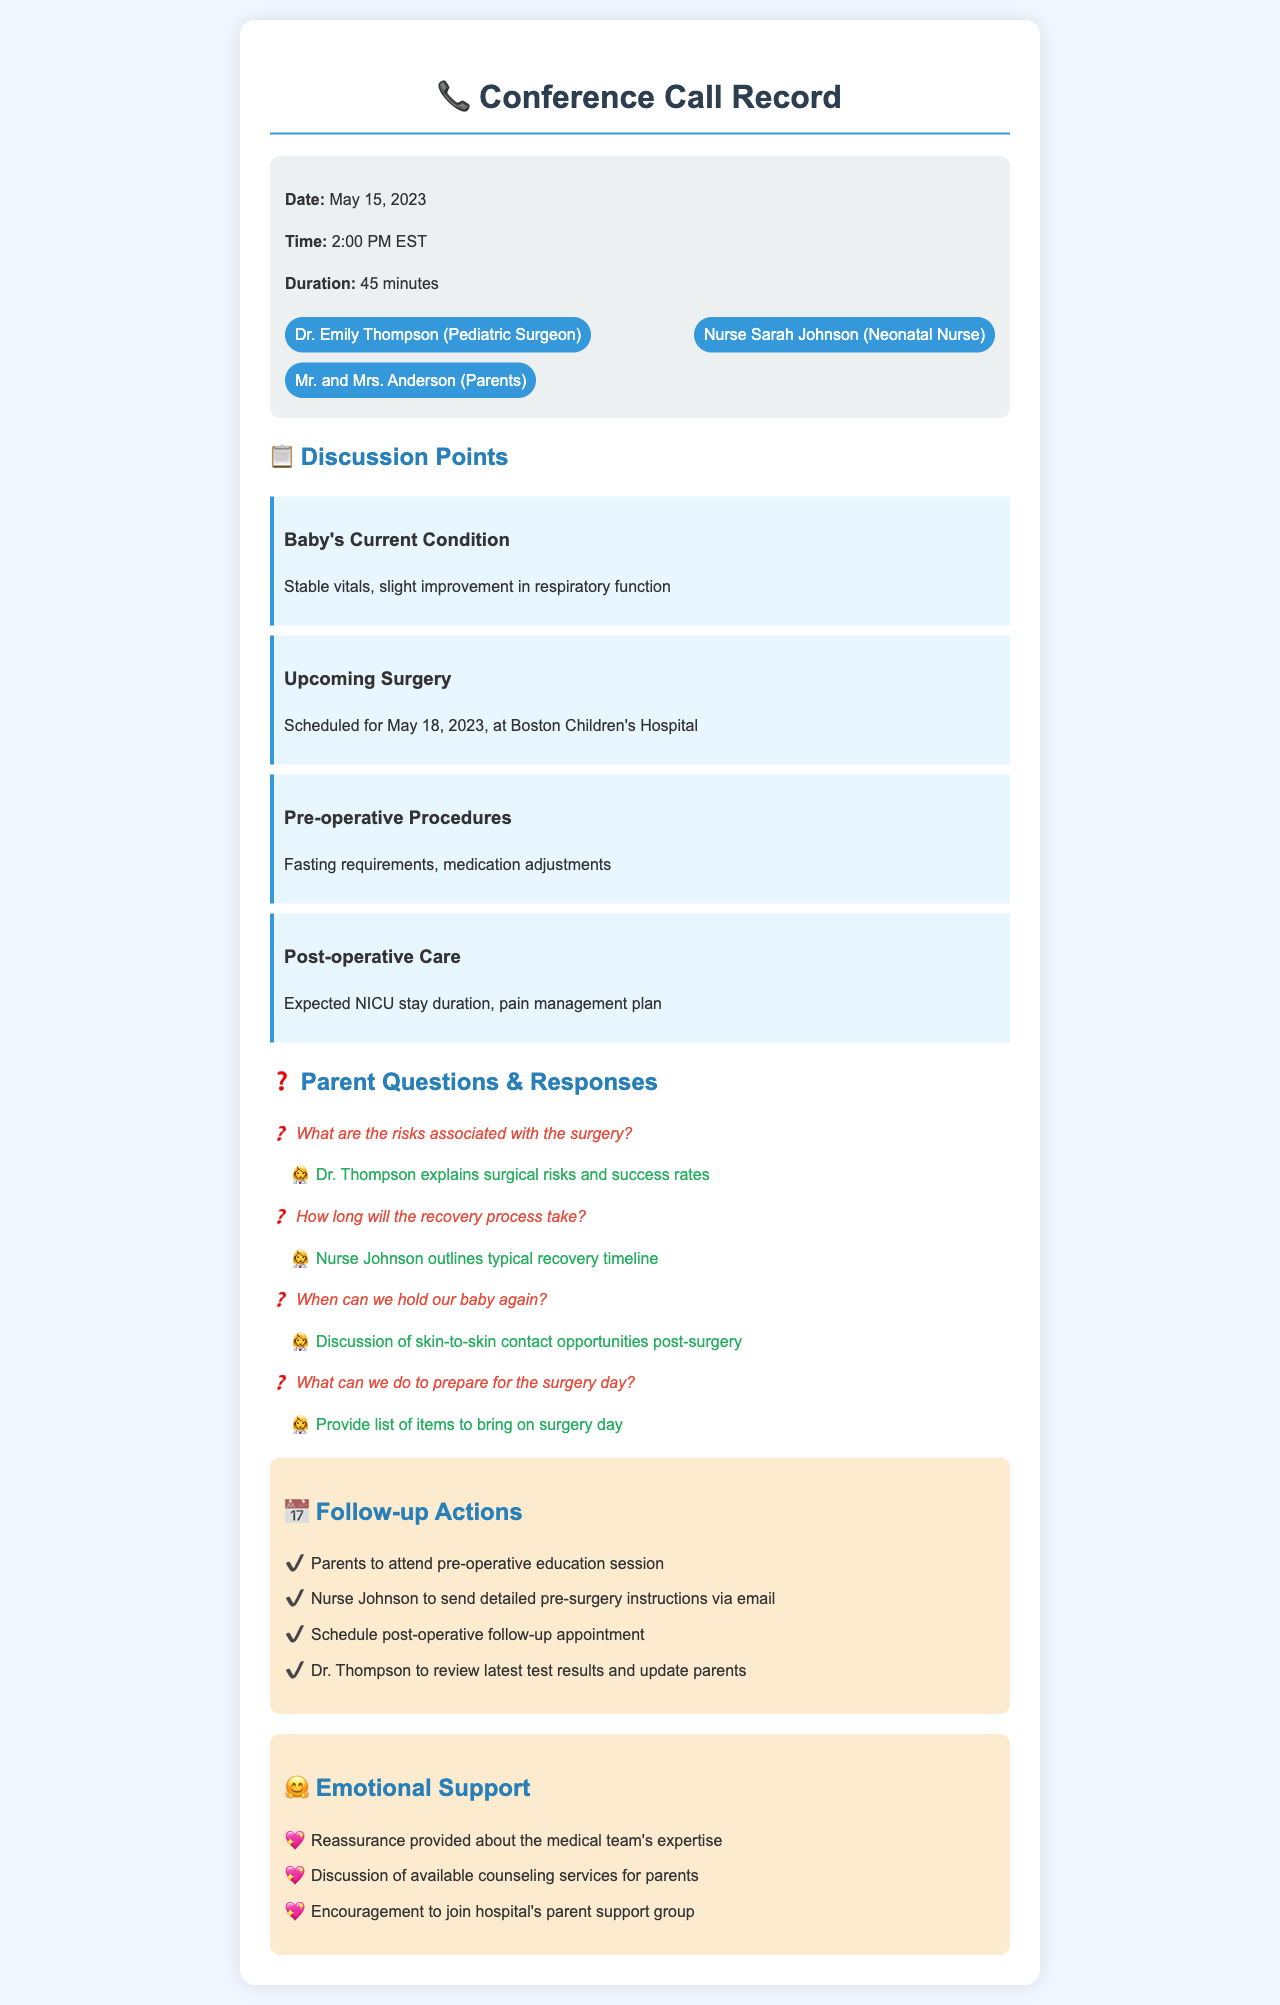What is the date of the conference call? The date of the conference call is explicitly stated in the document under call details.
Answer: May 15, 2023 Who is the pediatric surgeon? The document lists the participants of the call, including the pediatric surgeon's name.
Answer: Dr. Emily Thompson When is the upcoming surgery scheduled? The document includes details about the surgery, mentioning the specific date.
Answer: May 18, 2023 What is discussed regarding the baby's current condition? The document highlights the baby's condition with specific descriptors provided in the discussion points.
Answer: Stable vitals, slight improvement in respiratory function What actions are suggested for the pre-operative phase? The follow-up actions section provides a list of steps for parents to take prior to the surgery, including education sessions.
Answer: Attend pre-operative education session How long is the expected NICU stay duration mentioned? While the exact duration might not be explicitly stated, NICU care is outlined in the document under post-operative care.
Answer: Mention not specified What kind of support is offered for emotional well-being? The emotional support section of the document describes the types of support available for parents.
Answer: Counseling services for parents What is Nurse Johnson's role in the phone call? The document lists all participants and their roles, indicating what Nurse Johnson's contributions might include.
Answer: Neonatal Nurse What should parents prepare for on the surgery day? There is a discussion point that addresses what parents can do to prepare for the surgery day.
Answer: List of items to bring on surgery day 